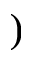Convert formula to latex. <formula><loc_0><loc_0><loc_500><loc_500>)</formula> 